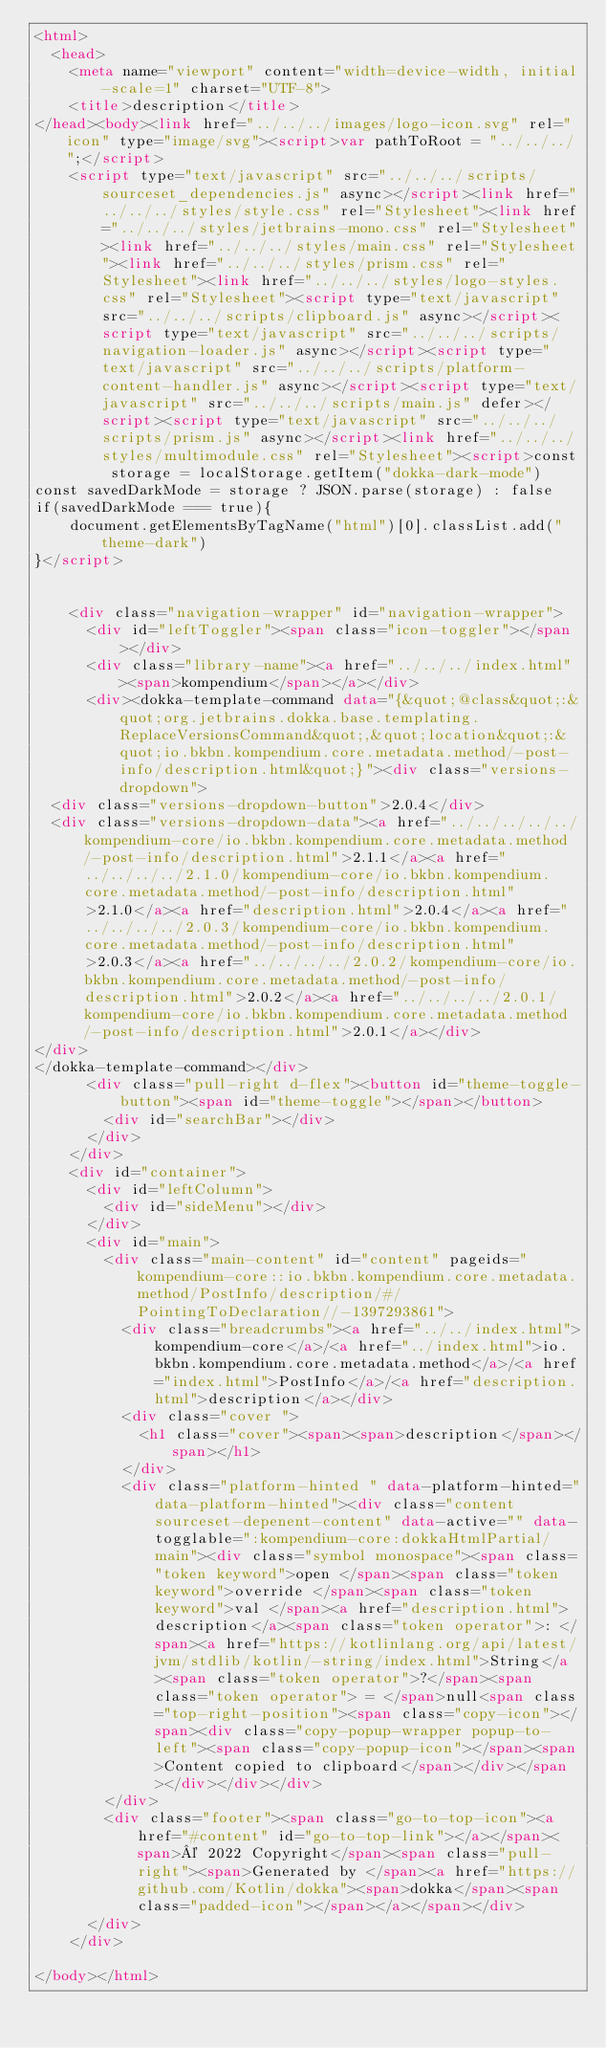Convert code to text. <code><loc_0><loc_0><loc_500><loc_500><_HTML_><html>
  <head>
    <meta name="viewport" content="width=device-width, initial-scale=1" charset="UTF-8">
    <title>description</title>
</head><body><link href="../../../images/logo-icon.svg" rel="icon" type="image/svg"><script>var pathToRoot = "../../../";</script>
    <script type="text/javascript" src="../../../scripts/sourceset_dependencies.js" async></script><link href="../../../styles/style.css" rel="Stylesheet"><link href="../../../styles/jetbrains-mono.css" rel="Stylesheet"><link href="../../../styles/main.css" rel="Stylesheet"><link href="../../../styles/prism.css" rel="Stylesheet"><link href="../../../styles/logo-styles.css" rel="Stylesheet"><script type="text/javascript" src="../../../scripts/clipboard.js" async></script><script type="text/javascript" src="../../../scripts/navigation-loader.js" async></script><script type="text/javascript" src="../../../scripts/platform-content-handler.js" async></script><script type="text/javascript" src="../../../scripts/main.js" defer></script><script type="text/javascript" src="../../../scripts/prism.js" async></script><link href="../../../styles/multimodule.css" rel="Stylesheet"><script>const storage = localStorage.getItem("dokka-dark-mode")
const savedDarkMode = storage ? JSON.parse(storage) : false
if(savedDarkMode === true){
    document.getElementsByTagName("html")[0].classList.add("theme-dark")
}</script>

  
    <div class="navigation-wrapper" id="navigation-wrapper">
      <div id="leftToggler"><span class="icon-toggler"></span></div>
      <div class="library-name"><a href="../../../index.html"><span>kompendium</span></a></div>
      <div><dokka-template-command data="{&quot;@class&quot;:&quot;org.jetbrains.dokka.base.templating.ReplaceVersionsCommand&quot;,&quot;location&quot;:&quot;io.bkbn.kompendium.core.metadata.method/-post-info/description.html&quot;}"><div class="versions-dropdown">
  <div class="versions-dropdown-button">2.0.4</div>
  <div class="versions-dropdown-data"><a href="../../../../../kompendium-core/io.bkbn.kompendium.core.metadata.method/-post-info/description.html">2.1.1</a><a href="../../../../2.1.0/kompendium-core/io.bkbn.kompendium.core.metadata.method/-post-info/description.html">2.1.0</a><a href="description.html">2.0.4</a><a href="../../../../2.0.3/kompendium-core/io.bkbn.kompendium.core.metadata.method/-post-info/description.html">2.0.3</a><a href="../../../../2.0.2/kompendium-core/io.bkbn.kompendium.core.metadata.method/-post-info/description.html">2.0.2</a><a href="../../../../2.0.1/kompendium-core/io.bkbn.kompendium.core.metadata.method/-post-info/description.html">2.0.1</a></div>
</div>
</dokka-template-command></div>
      <div class="pull-right d-flex"><button id="theme-toggle-button"><span id="theme-toggle"></span></button>
        <div id="searchBar"></div>
      </div>
    </div>
    <div id="container">
      <div id="leftColumn">
        <div id="sideMenu"></div>
      </div>
      <div id="main">
        <div class="main-content" id="content" pageids="kompendium-core::io.bkbn.kompendium.core.metadata.method/PostInfo/description/#/PointingToDeclaration//-1397293861">
          <div class="breadcrumbs"><a href="../../index.html">kompendium-core</a>/<a href="../index.html">io.bkbn.kompendium.core.metadata.method</a>/<a href="index.html">PostInfo</a>/<a href="description.html">description</a></div>
          <div class="cover ">
            <h1 class="cover"><span><span>description</span></span></h1>
          </div>
          <div class="platform-hinted " data-platform-hinted="data-platform-hinted"><div class="content sourceset-depenent-content" data-active="" data-togglable=":kompendium-core:dokkaHtmlPartial/main"><div class="symbol monospace"><span class="token keyword">open </span><span class="token keyword">override </span><span class="token keyword">val </span><a href="description.html">description</a><span class="token operator">: </span><a href="https://kotlinlang.org/api/latest/jvm/stdlib/kotlin/-string/index.html">String</a><span class="token operator">?</span><span class="token operator"> = </span>null<span class="top-right-position"><span class="copy-icon"></span><div class="copy-popup-wrapper popup-to-left"><span class="copy-popup-icon"></span><span>Content copied to clipboard</span></div></span></div></div></div>
        </div>
        <div class="footer"><span class="go-to-top-icon"><a href="#content" id="go-to-top-link"></a></span><span>© 2022 Copyright</span><span class="pull-right"><span>Generated by </span><a href="https://github.com/Kotlin/dokka"><span>dokka</span><span class="padded-icon"></span></a></span></div>
      </div>
    </div>
  
</body></html>



</code> 